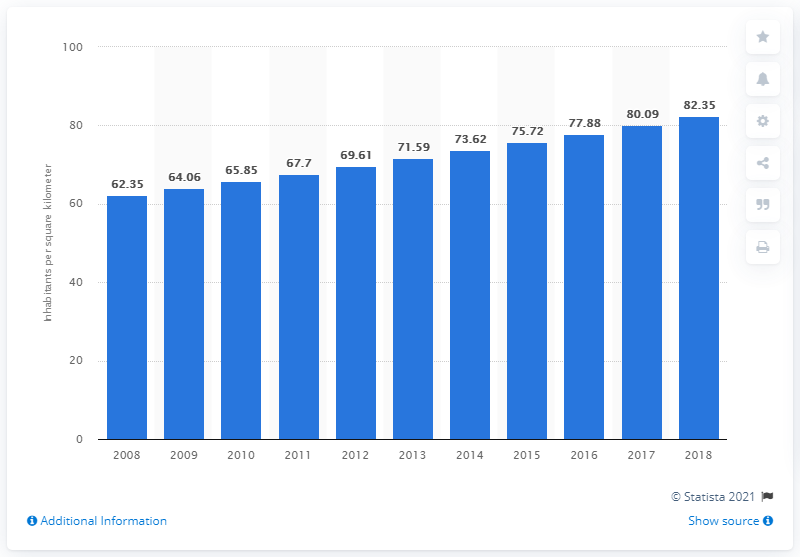Mention a couple of crucial points in this snapshot. In 2018, the population density of Senegal was 82.35 people per square kilometer. 